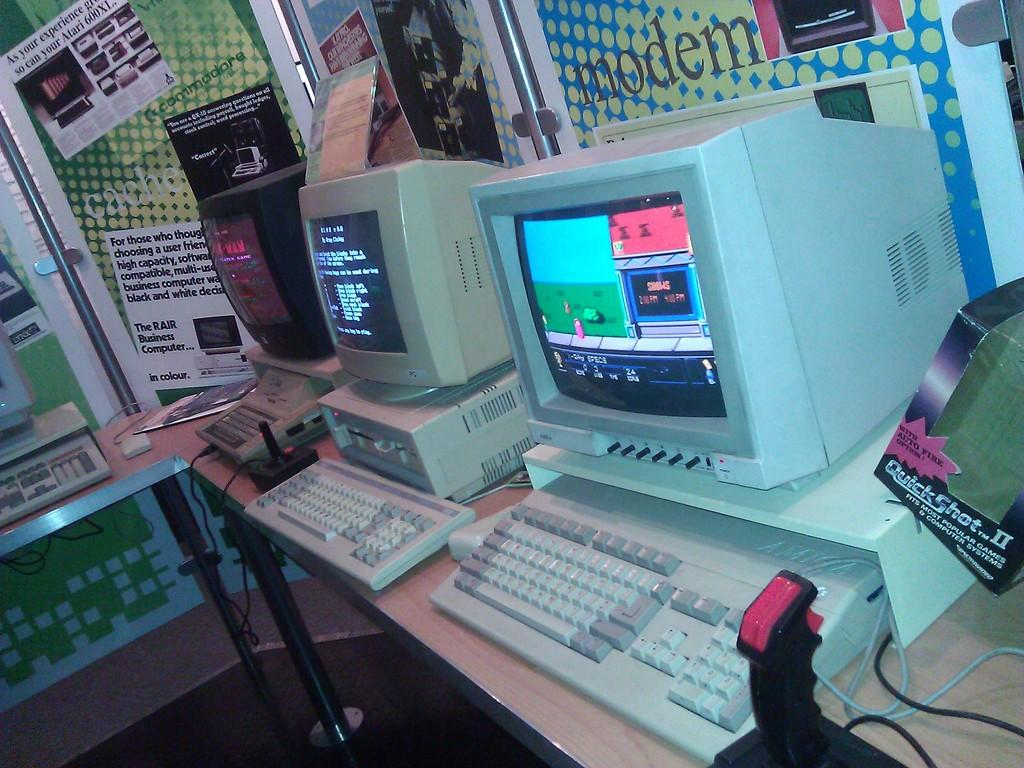Provide a one-sentence caption for the provided image. Some old style computers and a box reading Quick Shot to the right. 